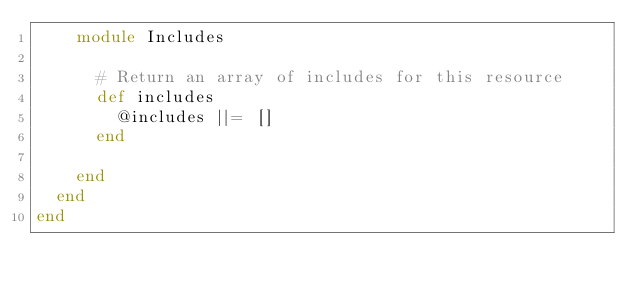Convert code to text. <code><loc_0><loc_0><loc_500><loc_500><_Ruby_>    module Includes

      # Return an array of includes for this resource
      def includes
        @includes ||= []
      end

    end
  end
end
</code> 